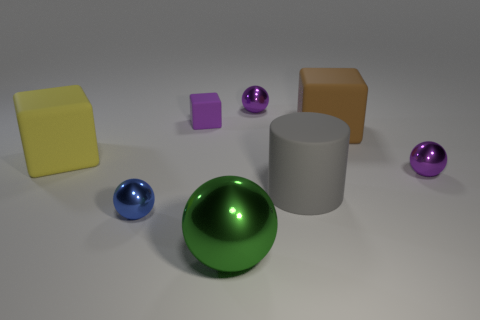There is a ball that is both right of the large green object and on the left side of the big brown cube; what is its material?
Provide a succinct answer. Metal. There is a blue metallic thing; is its shape the same as the purple object in front of the large yellow object?
Offer a very short reply. Yes. How many other objects are the same size as the brown cube?
Offer a terse response. 3. Is the number of small purple blocks greater than the number of big red matte cylinders?
Your answer should be compact. Yes. How many objects are behind the large yellow matte thing and on the right side of the small matte thing?
Your answer should be compact. 2. What shape is the purple object on the right side of the large gray thing left of the big matte object right of the gray rubber object?
Provide a succinct answer. Sphere. Is there any other thing that has the same shape as the brown object?
Provide a short and direct response. Yes. How many cylinders are either cyan rubber objects or gray matte objects?
Offer a very short reply. 1. There is a small metallic sphere that is to the right of the big cylinder; is its color the same as the small rubber block?
Give a very brief answer. Yes. There is a purple ball that is right of the big cube that is on the right side of the blue shiny ball that is to the right of the yellow thing; what is it made of?
Your answer should be compact. Metal. 